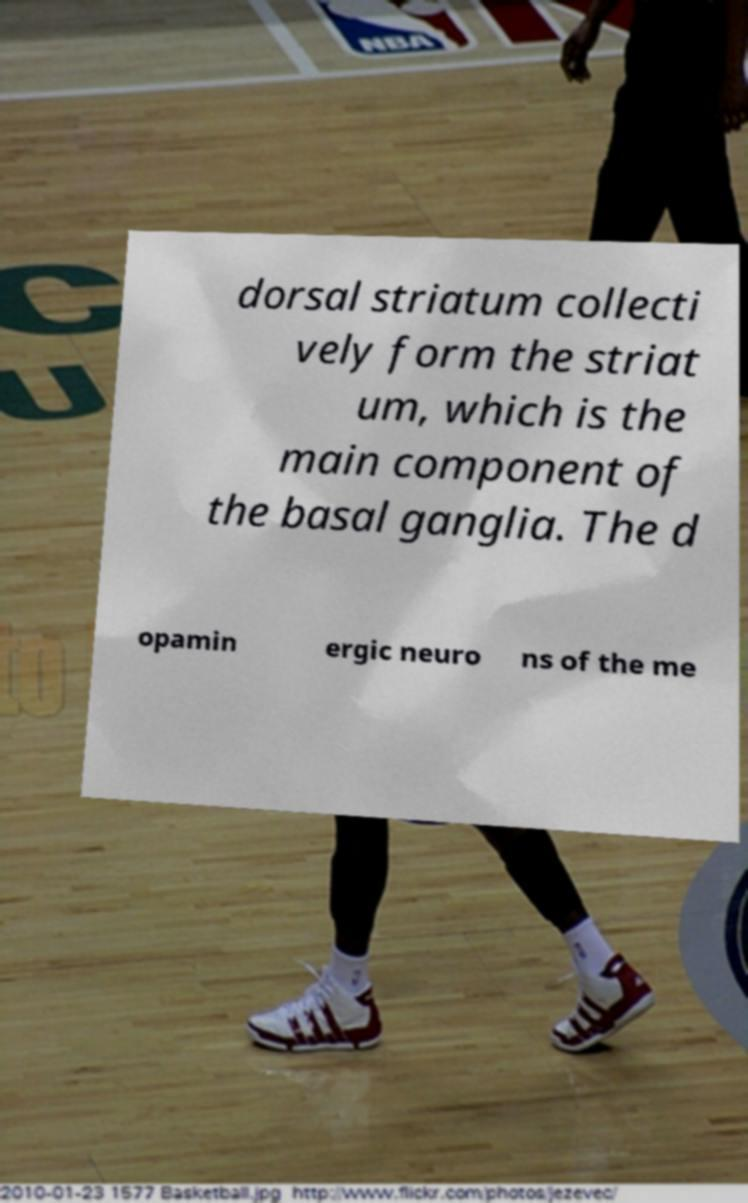Please read and relay the text visible in this image. What does it say? dorsal striatum collecti vely form the striat um, which is the main component of the basal ganglia. The d opamin ergic neuro ns of the me 